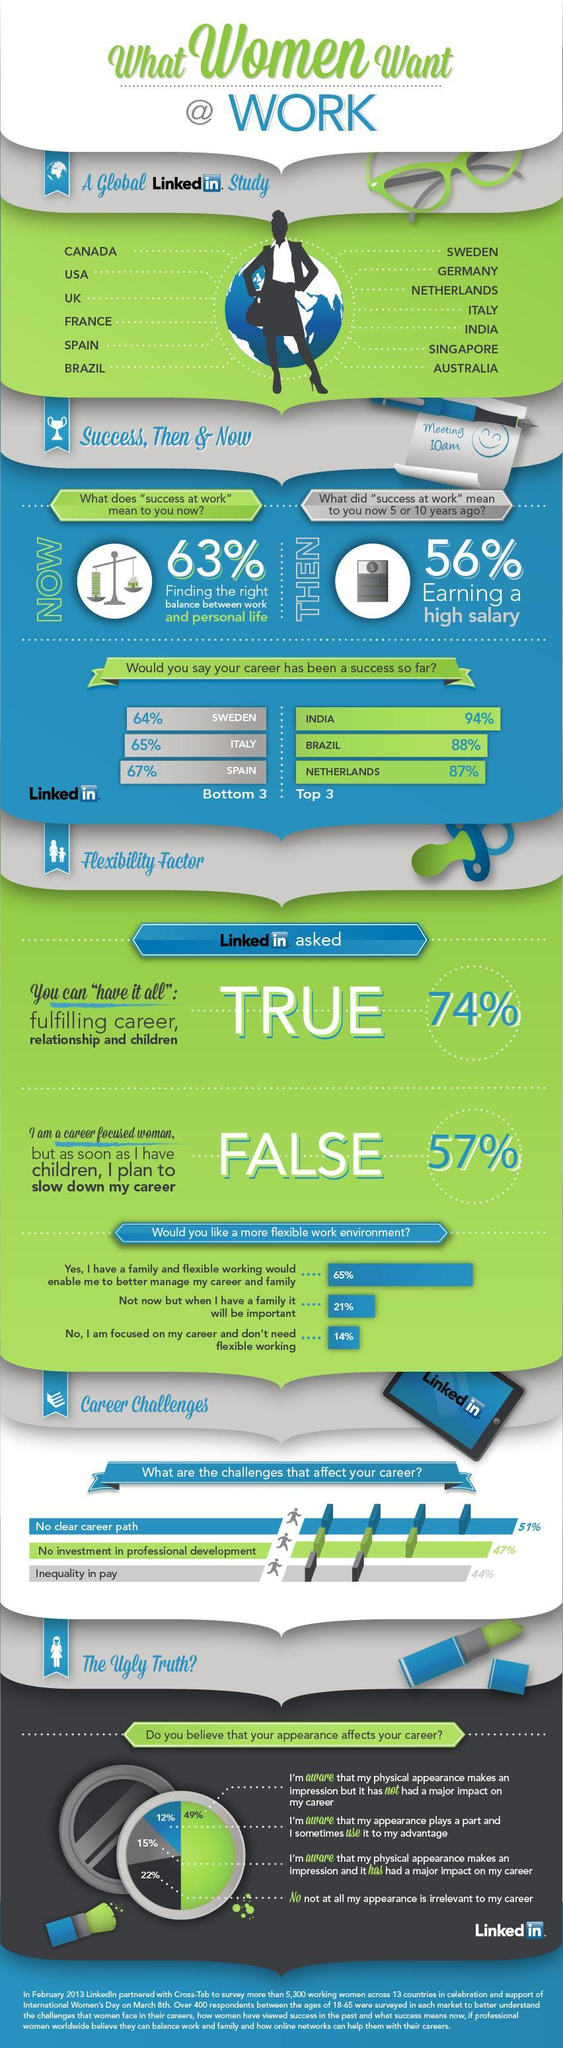What does success at work mean now
Answer the question with a short phrase. finding the right balance between work and personal life what % think that we can't have it all, fulfilling career, relationship and children 26 how many countries were included in the global linkedin study 13 WHat are the challenges that affect your career no clear career path, no investment in professional development, inequality in pay What % of women plan to slow down their career after having children 43 What did success at work mean 5 or 10 years ago earning a high salary 